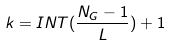<formula> <loc_0><loc_0><loc_500><loc_500>k = I N T ( \frac { N _ { G } - 1 } { L } ) + 1</formula> 